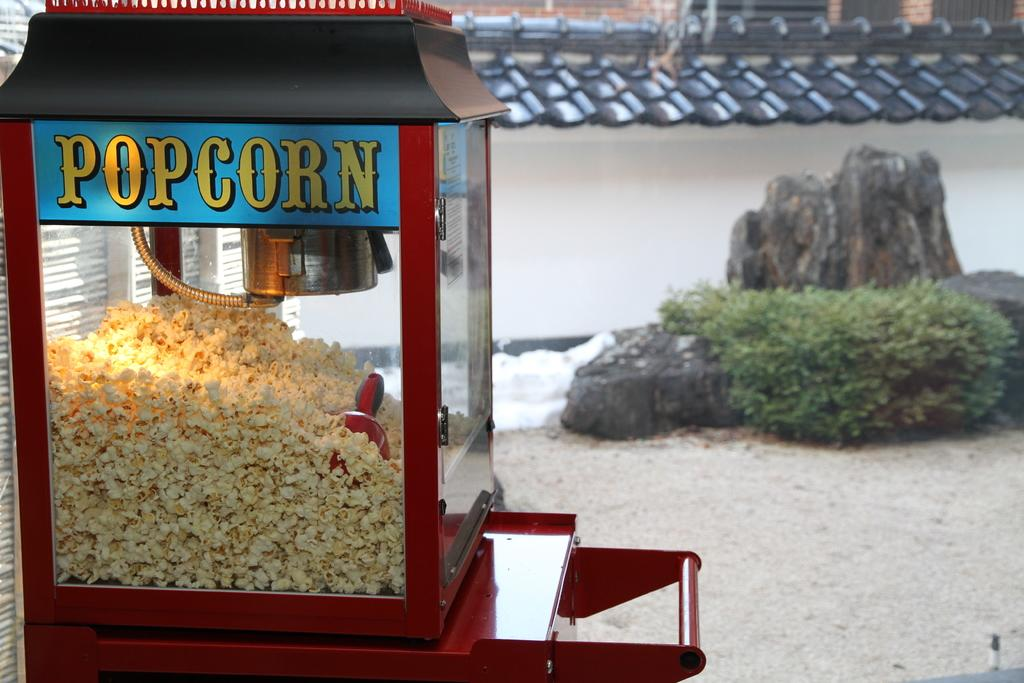<image>
Write a terse but informative summary of the picture. A machine has the word "Popcorn" painted on the side in yellow text on a blue background. 